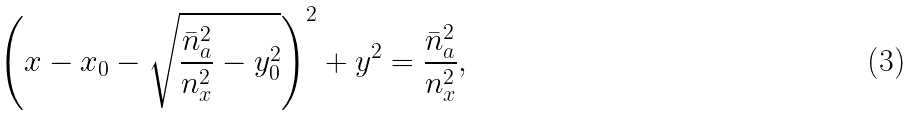Convert formula to latex. <formula><loc_0><loc_0><loc_500><loc_500>\left ( x - x _ { 0 } - \sqrt { \frac { \bar { n } _ { a } ^ { 2 } } { n _ { x } ^ { 2 } } - y _ { 0 } ^ { 2 } } \right ) ^ { 2 } + y ^ { 2 } = \frac { \bar { n } _ { a } ^ { 2 } } { n _ { x } ^ { 2 } } ,</formula> 